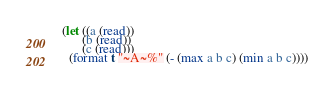Convert code to text. <code><loc_0><loc_0><loc_500><loc_500><_Lisp_>(let ((a (read))
      (b (read))
      (c (read)))
  (format t "~A~%" (- (max a b c) (min a b c))))
</code> 